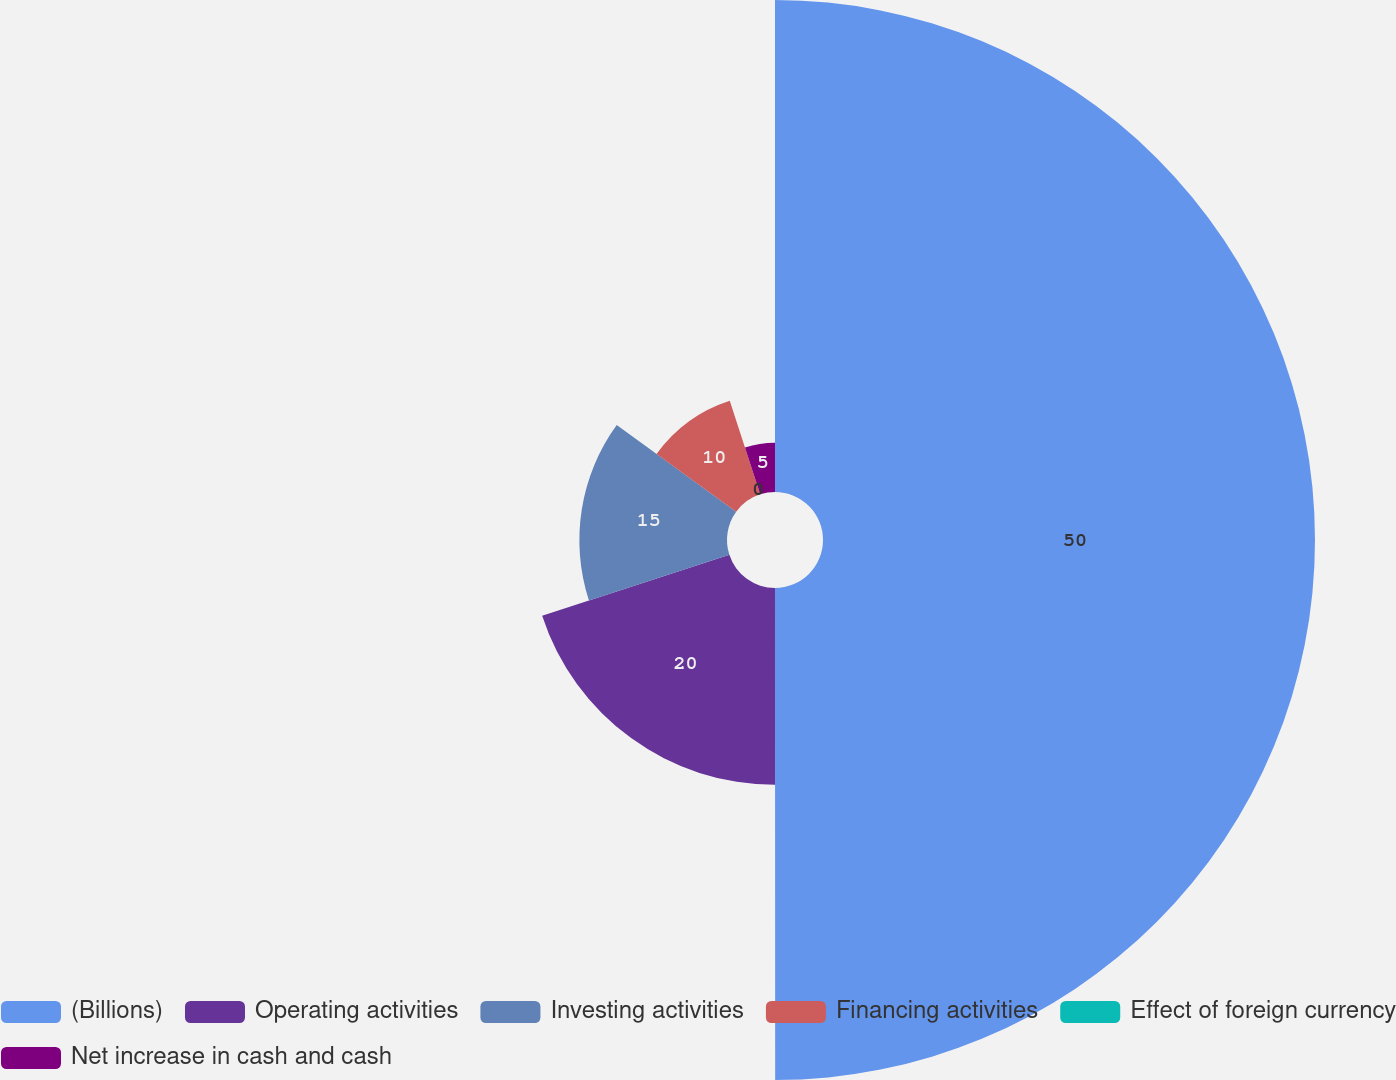Convert chart. <chart><loc_0><loc_0><loc_500><loc_500><pie_chart><fcel>(Billions)<fcel>Operating activities<fcel>Investing activities<fcel>Financing activities<fcel>Effect of foreign currency<fcel>Net increase in cash and cash<nl><fcel>49.99%<fcel>20.0%<fcel>15.0%<fcel>10.0%<fcel>0.0%<fcel>5.0%<nl></chart> 